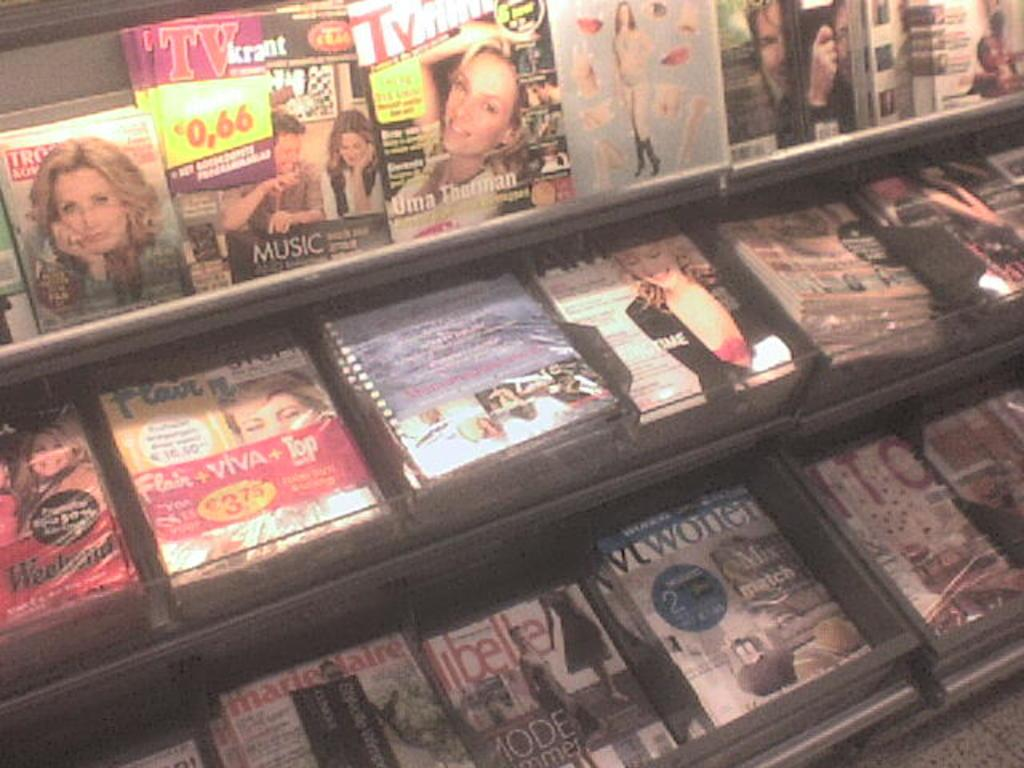What type of storage units are visible in the image? There are shelves in the image. What items can be seen on the shelves? There are boxes present on the shelves. How does the fork help the shop breathe in the image? There is no fork or shop present in the image, and therefore no such interaction can be observed. 